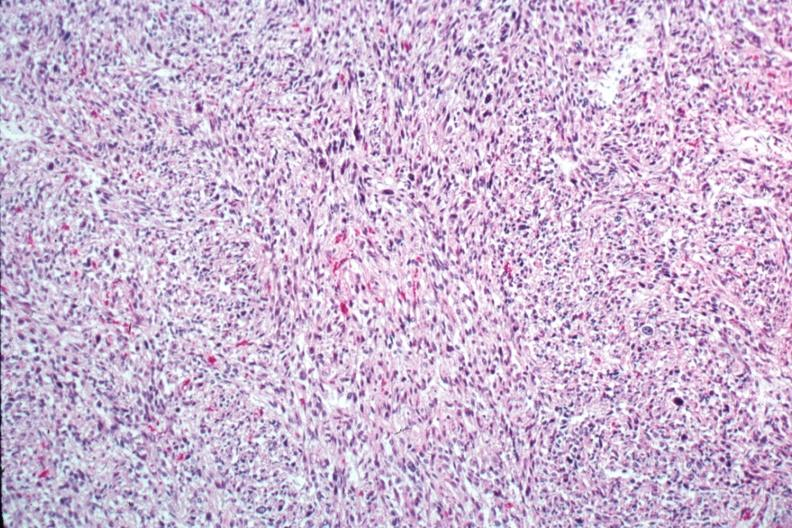what is present?
Answer the question using a single word or phrase. Leiomyosarcoma 